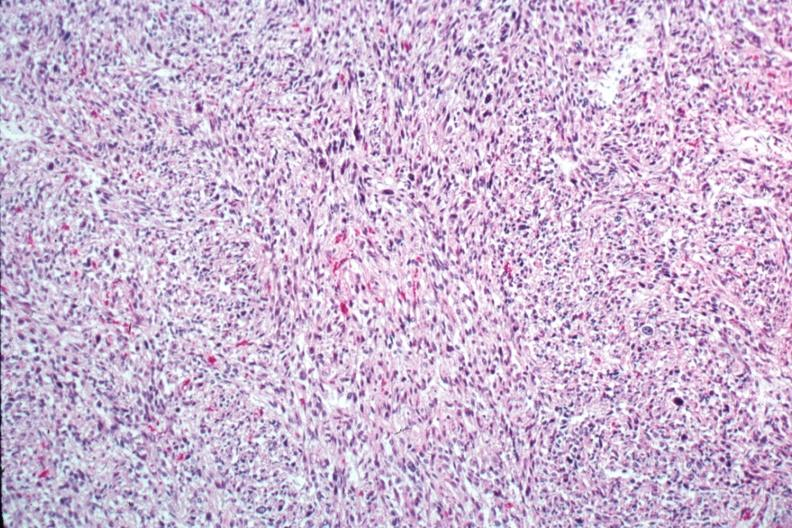what is present?
Answer the question using a single word or phrase. Leiomyosarcoma 